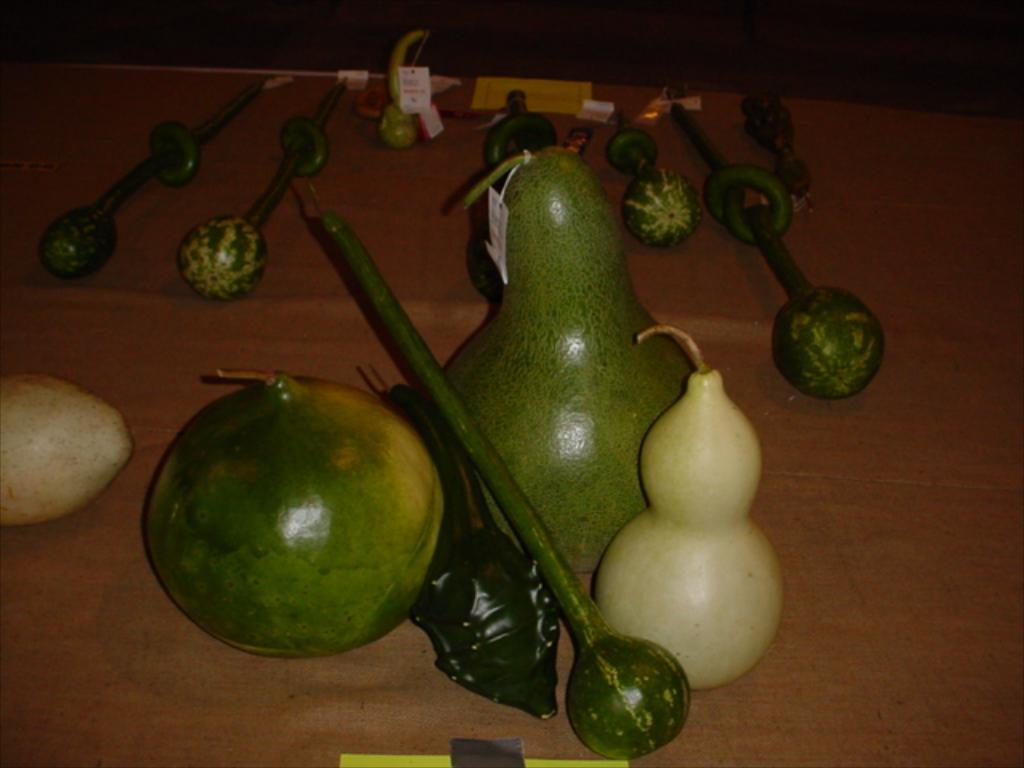What type of food can be seen in the image? There are vegetables in the image. What else can be found on the table in the image? There are other objects on the table in the image, but their specific details are not mentioned in the provided facts. How many children are playing with the coil on the floor in the image? There is no mention of children, a coil, or the floor in the provided facts, so we cannot answer this question based on the given information. 